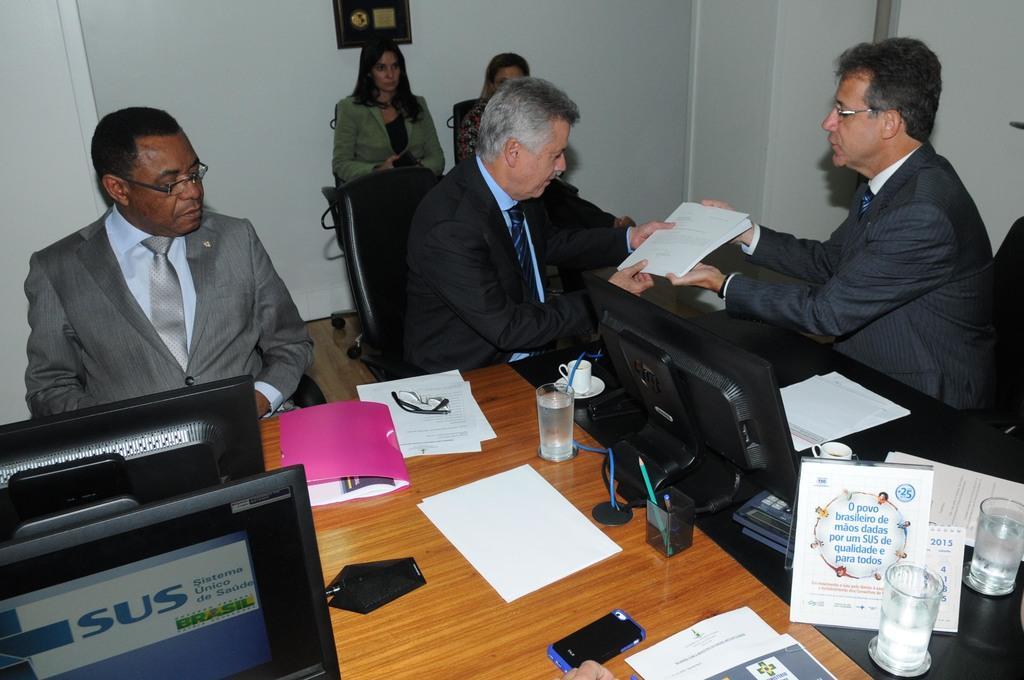Can you describe this image briefly? In this image, there are a few people. Among them, some people are holding some object. We can also see a table with some objects like glasses, posters and screens. We can see the wall with some object. 